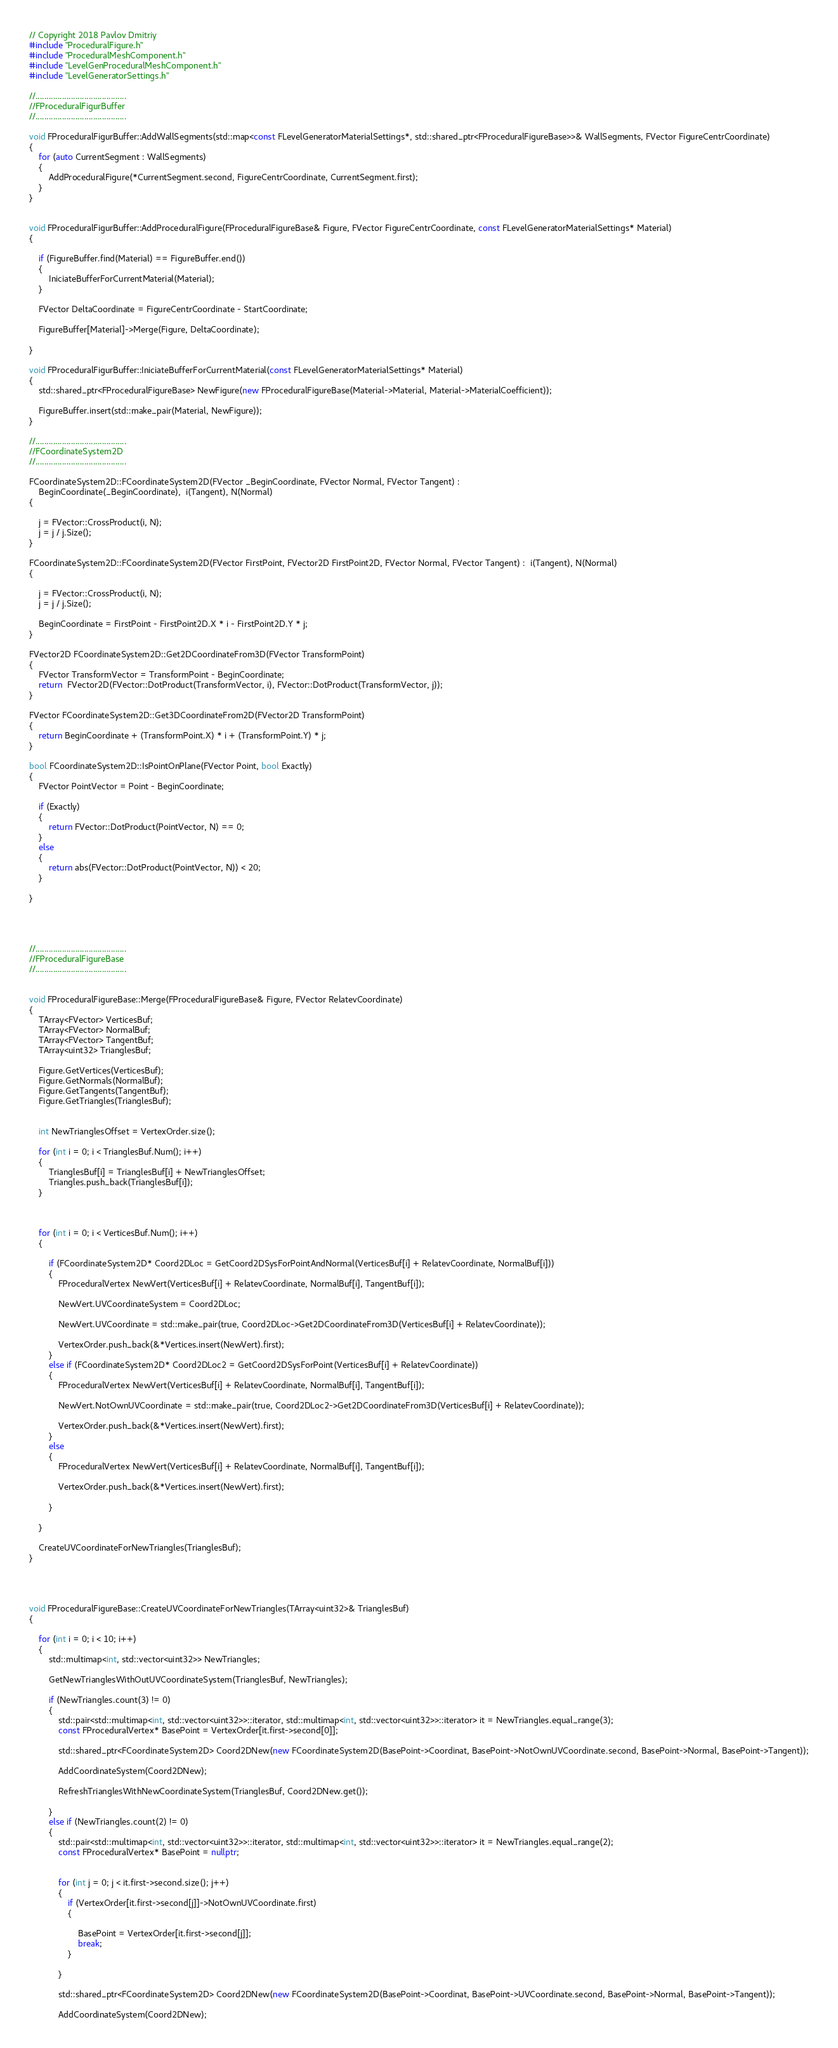Convert code to text. <code><loc_0><loc_0><loc_500><loc_500><_C++_>// Copyright 2018 Pavlov Dmitriy
#include "ProceduralFigure.h"
#include "ProceduralMeshComponent.h"
#include "LevelGenProceduralMeshComponent.h"
#include "LevelGeneratorSettings.h"

//.........................................
//FProceduralFigurBuffer
//.........................................

void FProceduralFigurBuffer::AddWallSegments(std::map<const FLevelGeneratorMaterialSettings*, std::shared_ptr<FProceduralFigureBase>>& WallSegments, FVector FigureCentrCoordinate)
{
	for (auto CurrentSegment : WallSegments)
	{
		AddProceduralFigure(*CurrentSegment.second, FigureCentrCoordinate, CurrentSegment.first);
	}
}


void FProceduralFigurBuffer::AddProceduralFigure(FProceduralFigureBase& Figure, FVector FigureCentrCoordinate, const FLevelGeneratorMaterialSettings* Material)
{
	
	if (FigureBuffer.find(Material) == FigureBuffer.end())
	{
		IniciateBufferForCurrentMaterial(Material);
	}

	FVector DeltaCoordinate = FigureCentrCoordinate - StartCoordinate;

	FigureBuffer[Material]->Merge(Figure, DeltaCoordinate);
	
}

void FProceduralFigurBuffer::IniciateBufferForCurrentMaterial(const FLevelGeneratorMaterialSettings* Material)
{
	std::shared_ptr<FProceduralFigureBase> NewFigure(new FProceduralFigureBase(Material->Material, Material->MaterialCoefficient));

	FigureBuffer.insert(std::make_pair(Material, NewFigure));
}

//.........................................
//FCoordinateSystem2D
//.........................................

FCoordinateSystem2D::FCoordinateSystem2D(FVector _BeginCoordinate, FVector Normal, FVector Tangent) :
	BeginCoordinate(_BeginCoordinate),  i(Tangent), N(Normal)
{

	j = FVector::CrossProduct(i, N);
	j = j / j.Size();
}

FCoordinateSystem2D::FCoordinateSystem2D(FVector FirstPoint, FVector2D FirstPoint2D, FVector Normal, FVector Tangent) :  i(Tangent), N(Normal)
{

	j = FVector::CrossProduct(i, N);
	j = j / j.Size();

	BeginCoordinate = FirstPoint - FirstPoint2D.X * i - FirstPoint2D.Y * j;
}

FVector2D FCoordinateSystem2D::Get2DCoordinateFrom3D(FVector TransformPoint)
{
	FVector TransformVector = TransformPoint - BeginCoordinate;
	return  FVector2D(FVector::DotProduct(TransformVector, i), FVector::DotProduct(TransformVector, j));
}

FVector FCoordinateSystem2D::Get3DCoordinateFrom2D(FVector2D TransformPoint)
{
	return BeginCoordinate + (TransformPoint.X) * i + (TransformPoint.Y) * j;
}

bool FCoordinateSystem2D::IsPointOnPlane(FVector Point, bool Exactly)
{
	FVector PointVector = Point - BeginCoordinate;

	if (Exactly)
	{
		return FVector::DotProduct(PointVector, N) == 0;
	}
	else
	{
		return abs(FVector::DotProduct(PointVector, N)) < 20;
	}

}




//.........................................
//FProceduralFigureBase
//.........................................


void FProceduralFigureBase::Merge(FProceduralFigureBase& Figure, FVector RelatevCoordinate)
{
	TArray<FVector> VerticesBuf;
	TArray<FVector> NormalBuf;
	TArray<FVector> TangentBuf;
	TArray<uint32> TrianglesBuf;

	Figure.GetVertices(VerticesBuf);
	Figure.GetNormals(NormalBuf);
	Figure.GetTangents(TangentBuf);
	Figure.GetTriangles(TrianglesBuf);

	
	int NewTrianglesOffset = VertexOrder.size();

	for (int i = 0; i < TrianglesBuf.Num(); i++)
	{
		TrianglesBuf[i] = TrianglesBuf[i] + NewTrianglesOffset;
		Triangles.push_back(TrianglesBuf[i]);
	}



	for (int i = 0; i < VerticesBuf.Num(); i++)
	{

		if (FCoordinateSystem2D* Coord2DLoc = GetCoord2DSysForPointAndNormal(VerticesBuf[i] + RelatevCoordinate, NormalBuf[i]))
		{
			FProceduralVertex NewVert(VerticesBuf[i] + RelatevCoordinate, NormalBuf[i], TangentBuf[i]);

			NewVert.UVCoordinateSystem = Coord2DLoc;

			NewVert.UVCoordinate = std::make_pair(true, Coord2DLoc->Get2DCoordinateFrom3D(VerticesBuf[i] + RelatevCoordinate));

			VertexOrder.push_back(&*Vertices.insert(NewVert).first);
		}
		else if (FCoordinateSystem2D* Coord2DLoc2 = GetCoord2DSysForPoint(VerticesBuf[i] + RelatevCoordinate))
		{
			FProceduralVertex NewVert(VerticesBuf[i] + RelatevCoordinate, NormalBuf[i], TangentBuf[i]);

			NewVert.NotOwnUVCoordinate = std::make_pair(true, Coord2DLoc2->Get2DCoordinateFrom3D(VerticesBuf[i] + RelatevCoordinate));

			VertexOrder.push_back(&*Vertices.insert(NewVert).first);
		}
		else
		{
			FProceduralVertex NewVert(VerticesBuf[i] + RelatevCoordinate, NormalBuf[i], TangentBuf[i]);

			VertexOrder.push_back(&*Vertices.insert(NewVert).first);

		}

	}

	CreateUVCoordinateForNewTriangles(TrianglesBuf);
}




void FProceduralFigureBase::CreateUVCoordinateForNewTriangles(TArray<uint32>& TrianglesBuf)
{

	for (int i = 0; i < 10; i++)
	{
		std::multimap<int, std::vector<uint32>> NewTriangles;

		GetNewTrianglesWithOutUVCoordinateSystem(TrianglesBuf, NewTriangles);

		if (NewTriangles.count(3) != 0)
		{
			std::pair<std::multimap<int, std::vector<uint32>>::iterator, std::multimap<int, std::vector<uint32>>::iterator> it = NewTriangles.equal_range(3);
			const FProceduralVertex* BasePoint = VertexOrder[it.first->second[0]];

			std::shared_ptr<FCoordinateSystem2D> Coord2DNew(new FCoordinateSystem2D(BasePoint->Coordinat, BasePoint->NotOwnUVCoordinate.second, BasePoint->Normal, BasePoint->Tangent));

			AddCoordinateSystem(Coord2DNew);

			RefreshTrianglesWithNewCoordinateSystem(TrianglesBuf, Coord2DNew.get());

		}
		else if (NewTriangles.count(2) != 0)
		{
			std::pair<std::multimap<int, std::vector<uint32>>::iterator, std::multimap<int, std::vector<uint32>>::iterator> it = NewTriangles.equal_range(2);
			const FProceduralVertex* BasePoint = nullptr;


			for (int j = 0; j < it.first->second.size(); j++)
			{
				if (VertexOrder[it.first->second[j]]->NotOwnUVCoordinate.first)
				{

					BasePoint = VertexOrder[it.first->second[j]];
					break;
				}

			}

			std::shared_ptr<FCoordinateSystem2D> Coord2DNew(new FCoordinateSystem2D(BasePoint->Coordinat, BasePoint->UVCoordinate.second, BasePoint->Normal, BasePoint->Tangent));

			AddCoordinateSystem(Coord2DNew);
</code> 